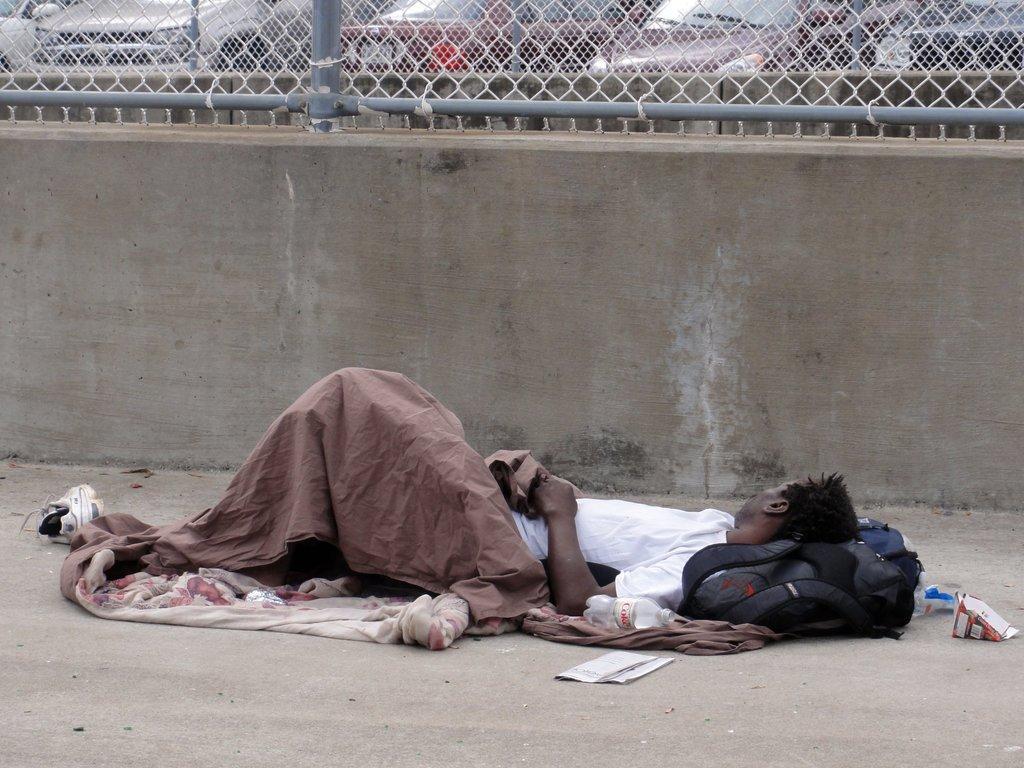How would you summarize this image in a sentence or two? In the foreground of this picture, there is a man laid down on the surface. In the background, there is a wall, fencing and behind it there are cars. 